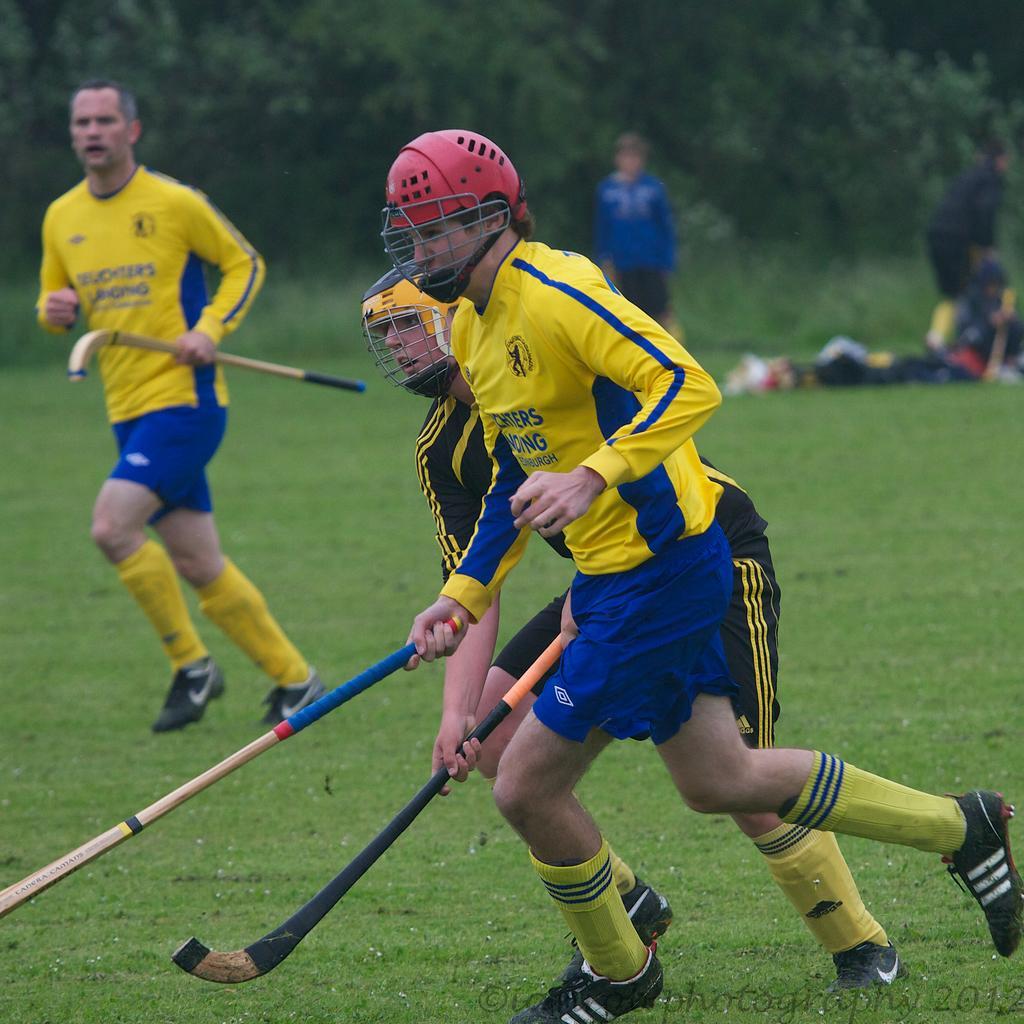Could you give a brief overview of what you see in this image? In front of the image there are two people wearing the helmets and they are holding the hockey sticks. Behind them there is another person holding the hockey stick. In the background of the image there are a few people. In front of them there are some objects. There are trees. At the bottom of the image there is grass on the surface. There is some text at the bottom of the image. 